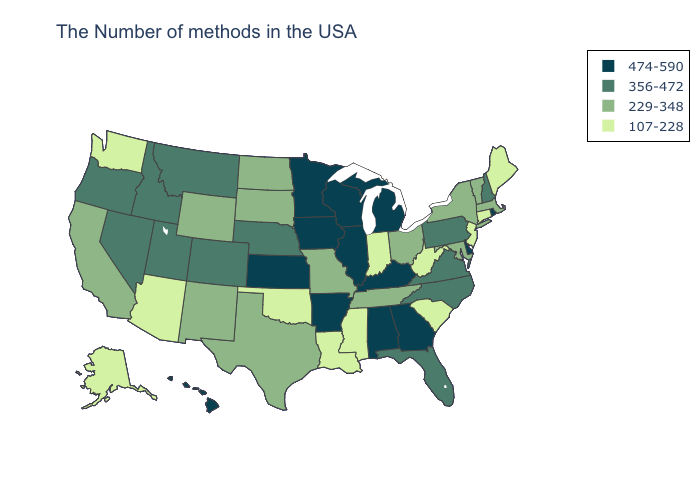Name the states that have a value in the range 356-472?
Keep it brief. New Hampshire, Pennsylvania, Virginia, North Carolina, Florida, Nebraska, Colorado, Utah, Montana, Idaho, Nevada, Oregon. What is the lowest value in the USA?
Give a very brief answer. 107-228. Does the first symbol in the legend represent the smallest category?
Quick response, please. No. Does Kentucky have the highest value in the South?
Be succinct. Yes. What is the highest value in the MidWest ?
Quick response, please. 474-590. What is the value of Wyoming?
Be succinct. 229-348. Name the states that have a value in the range 229-348?
Give a very brief answer. Massachusetts, Vermont, New York, Maryland, Ohio, Tennessee, Missouri, Texas, South Dakota, North Dakota, Wyoming, New Mexico, California. Does Missouri have the highest value in the MidWest?
Keep it brief. No. What is the value of Virginia?
Write a very short answer. 356-472. Does the map have missing data?
Give a very brief answer. No. What is the value of Washington?
Be succinct. 107-228. What is the lowest value in states that border Texas?
Write a very short answer. 107-228. What is the lowest value in the Northeast?
Write a very short answer. 107-228. Does West Virginia have the same value as Georgia?
Answer briefly. No. What is the value of New Jersey?
Keep it brief. 107-228. 